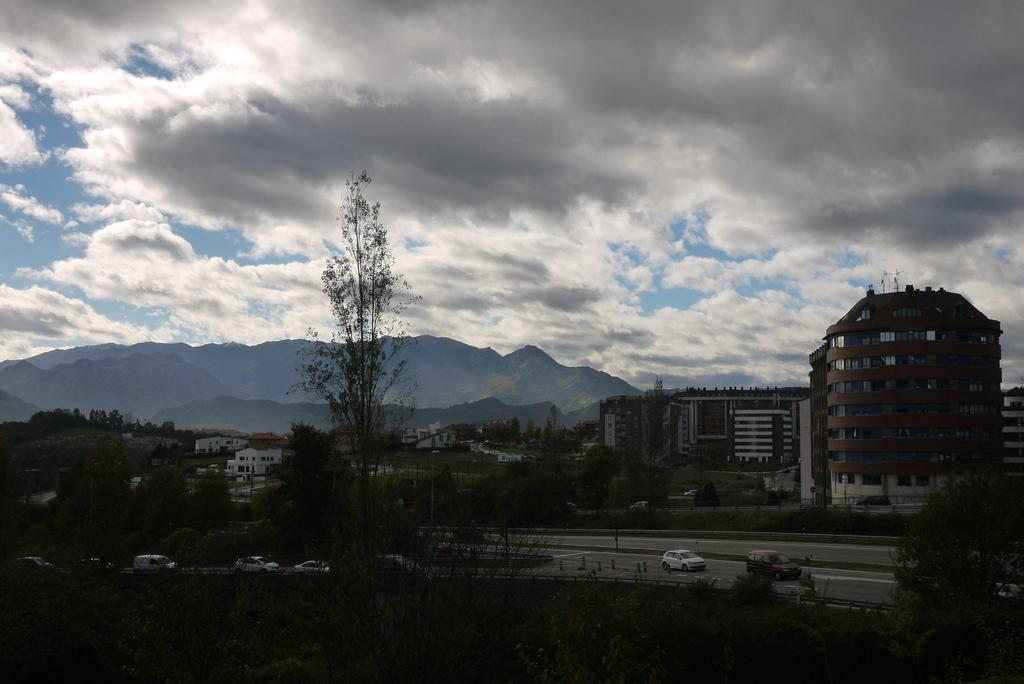What types of objects are present in the image? There are vehicles, trees, buildings, and mountains visible in the image. Can you describe the color of the trees in the image? The trees in the image have green color. What can be seen in the background of the image? There are mountains visible in the background of the image. How would you describe the color of the sky in the image? The sky is blue and white in color. What language is spoken by the plants in the image? There are no plants present in the image, and therefore no language can be attributed to them. How much power do the mountains generate in the image? There is no indication of power generation in the image, as it features vehicles, trees, buildings, and mountains. 